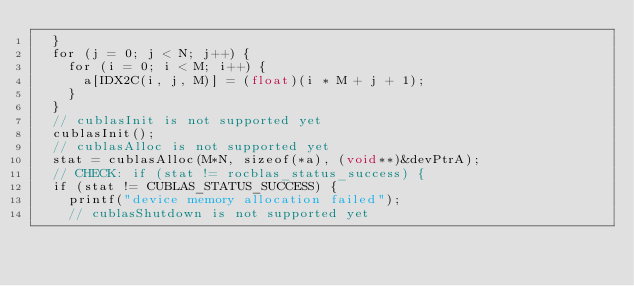Convert code to text. <code><loc_0><loc_0><loc_500><loc_500><_Cuda_>  }
  for (j = 0; j < N; j++) {
    for (i = 0; i < M; i++) {
      a[IDX2C(i, j, M)] = (float)(i * M + j + 1);
    }
  }
  // cublasInit is not supported yet
  cublasInit();
  // cublasAlloc is not supported yet
  stat = cublasAlloc(M*N, sizeof(*a), (void**)&devPtrA);
  // CHECK: if (stat != rocblas_status_success) {
  if (stat != CUBLAS_STATUS_SUCCESS) {
    printf("device memory allocation failed");
    // cublasShutdown is not supported yet</code> 